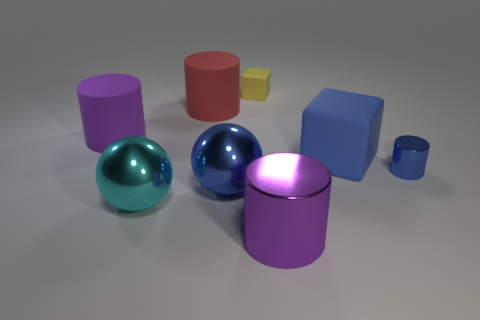Do the tiny cylinder and the big purple cylinder that is in front of the small shiny cylinder have the same material?
Offer a very short reply. Yes. What number of green objects are tiny things or matte things?
Offer a very short reply. 0. Is there a red cylinder that has the same size as the purple metal object?
Give a very brief answer. Yes. There is a large blue object that is left of the large purple cylinder that is in front of the purple cylinder that is to the left of the big blue metallic thing; what is it made of?
Make the answer very short. Metal. Are there an equal number of big cyan metal objects that are right of the yellow block and big cubes?
Ensure brevity in your answer.  No. Do the purple cylinder right of the large cyan shiny object and the tiny blue cylinder that is right of the large red cylinder have the same material?
Provide a short and direct response. Yes. What number of things are either large metal cylinders or large things that are to the left of the small cube?
Ensure brevity in your answer.  5. Is there a purple matte thing that has the same shape as the tiny metal thing?
Your response must be concise. Yes. There is a blue matte thing behind the big metallic ball that is to the left of the blue object that is in front of the tiny cylinder; what is its size?
Your answer should be compact. Large. Are there the same number of yellow matte cubes in front of the big cyan metal object and tiny metal cylinders on the left side of the purple metal cylinder?
Give a very brief answer. Yes. 